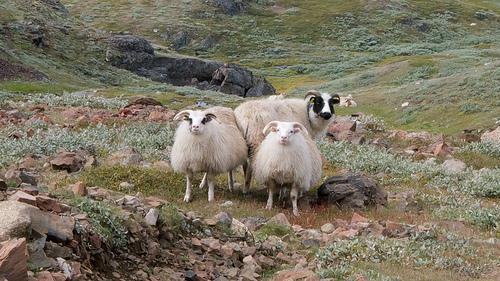How many animals are pictured?
Give a very brief answer. 3. 